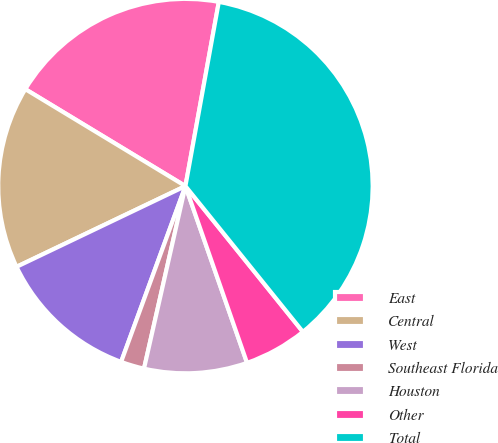<chart> <loc_0><loc_0><loc_500><loc_500><pie_chart><fcel>East<fcel>Central<fcel>West<fcel>Southeast Florida<fcel>Houston<fcel>Other<fcel>Total<nl><fcel>19.19%<fcel>15.76%<fcel>12.32%<fcel>2.03%<fcel>8.89%<fcel>5.46%<fcel>36.35%<nl></chart> 